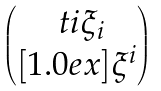Convert formula to latex. <formula><loc_0><loc_0><loc_500><loc_500>\begin{pmatrix} \, \ t i \xi _ { i } \, \\ [ 1 . 0 e x ] \xi ^ { i } \end{pmatrix}</formula> 